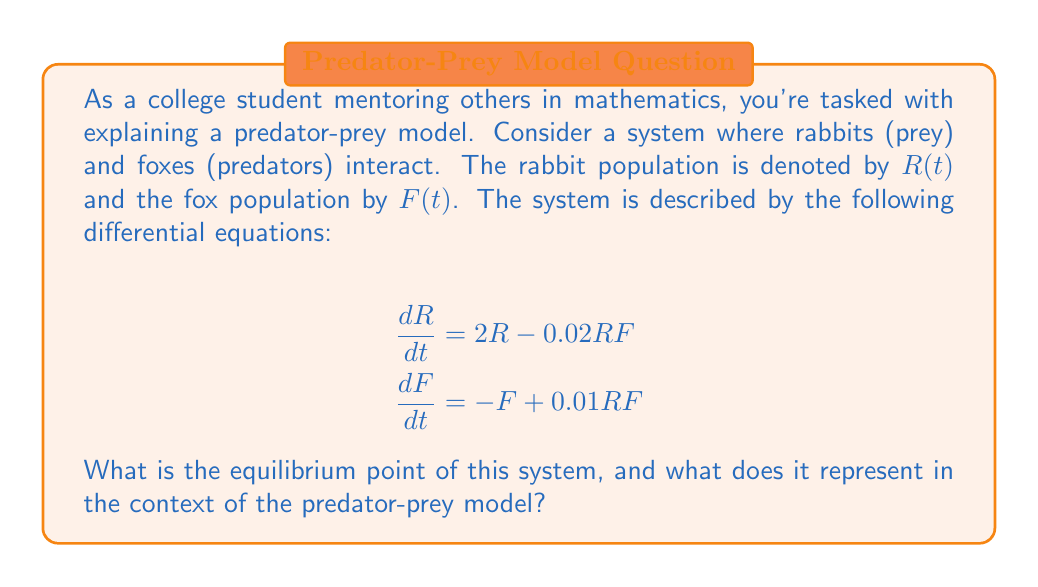Help me with this question. To find the equilibrium point, we need to set both differential equations to zero and solve for $R$ and $F$:

1) Set $\frac{dR}{dt} = 0$ and $\frac{dF}{dt} = 0$:

   $2R - 0.02RF = 0$
   $-F + 0.01RF = 0$

2) From the first equation:
   $2R - 0.02RF = 0$
   $R(2 - 0.02F) = 0$
   
   This is true when $R = 0$ or $F = 100$

3) From the second equation:
   $-F + 0.01RF = 0$
   $F(-1 + 0.01R) = 0$
   
   This is true when $F = 0$ or $R = 100$

4) The non-trivial solution is when $R = 100$ and $F = 100$

5) Therefore, the equilibrium point is $(R, F) = (100, 100)$

This equilibrium point represents a state where both populations remain constant over time. At this point:

- There are 100 rabbits and 100 foxes.
- The rabbit population growth rate exactly balances the rate at which they are being eaten by foxes.
- The fox death rate exactly balances the rate at which they are reproducing due to the availability of rabbits as food.

This is a stable coexistence of predators and prey in the ecosystem.
Answer: $(R, F) = (100, 100)$ 